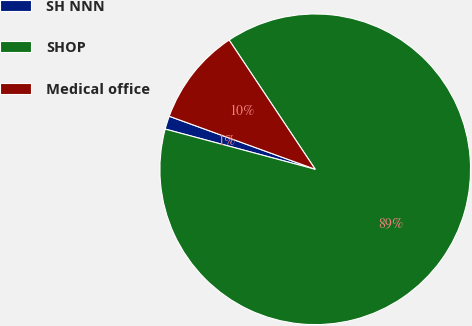<chart> <loc_0><loc_0><loc_500><loc_500><pie_chart><fcel>SH NNN<fcel>SHOP<fcel>Medical office<nl><fcel>1.38%<fcel>88.52%<fcel>10.1%<nl></chart> 